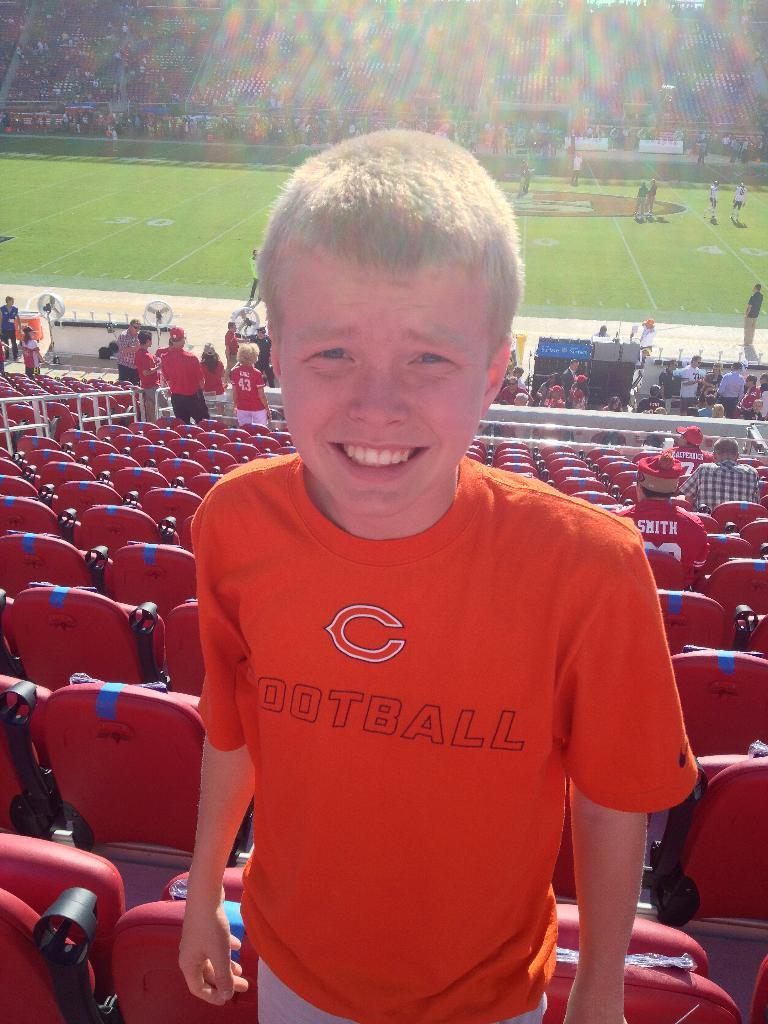What is the main subject of the image? A: There is a man standing in the image. What is located behind the man? There are chairs behind the man. What are the people on the chairs doing? Some people are sitting on the chairs. What can be seen in the background of the image? There is a stadium visible in the background of the image. What type of cat is sitting on the man's shoulder in the image? There is no cat present in the image. Is the man's sister sitting next to him in the image? The provided facts do not mention a sister, so we cannot determine if she is present in the image. 